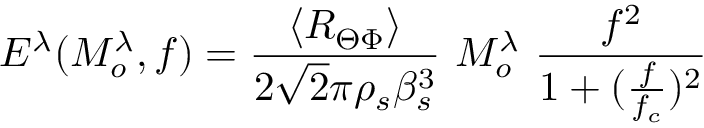<formula> <loc_0><loc_0><loc_500><loc_500>E ^ { \lambda } ( M _ { o } ^ { \lambda } , f ) = \frac { \langle R _ { \Theta \Phi } \rangle } { 2 \sqrt { 2 } \pi \rho _ { s } \beta _ { s } ^ { 3 } } M _ { o } ^ { \lambda } \frac { f ^ { 2 } } { 1 + ( \frac { f } { f _ { c } } ) ^ { 2 } }</formula> 